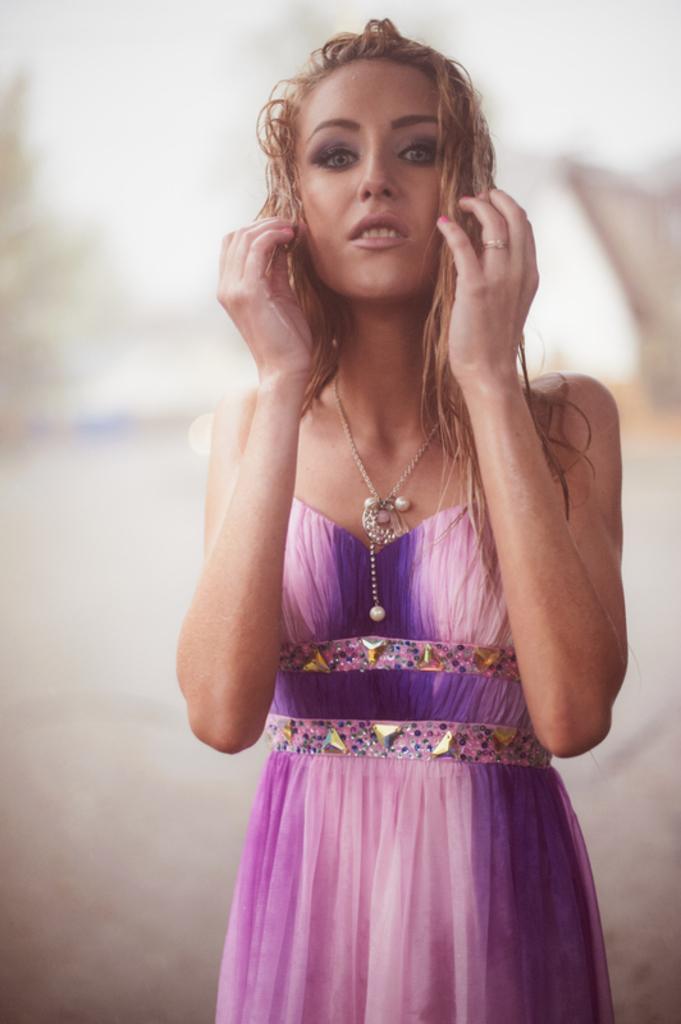In one or two sentences, can you explain what this image depicts? In this image there is a woman standing , and there is blur background. 